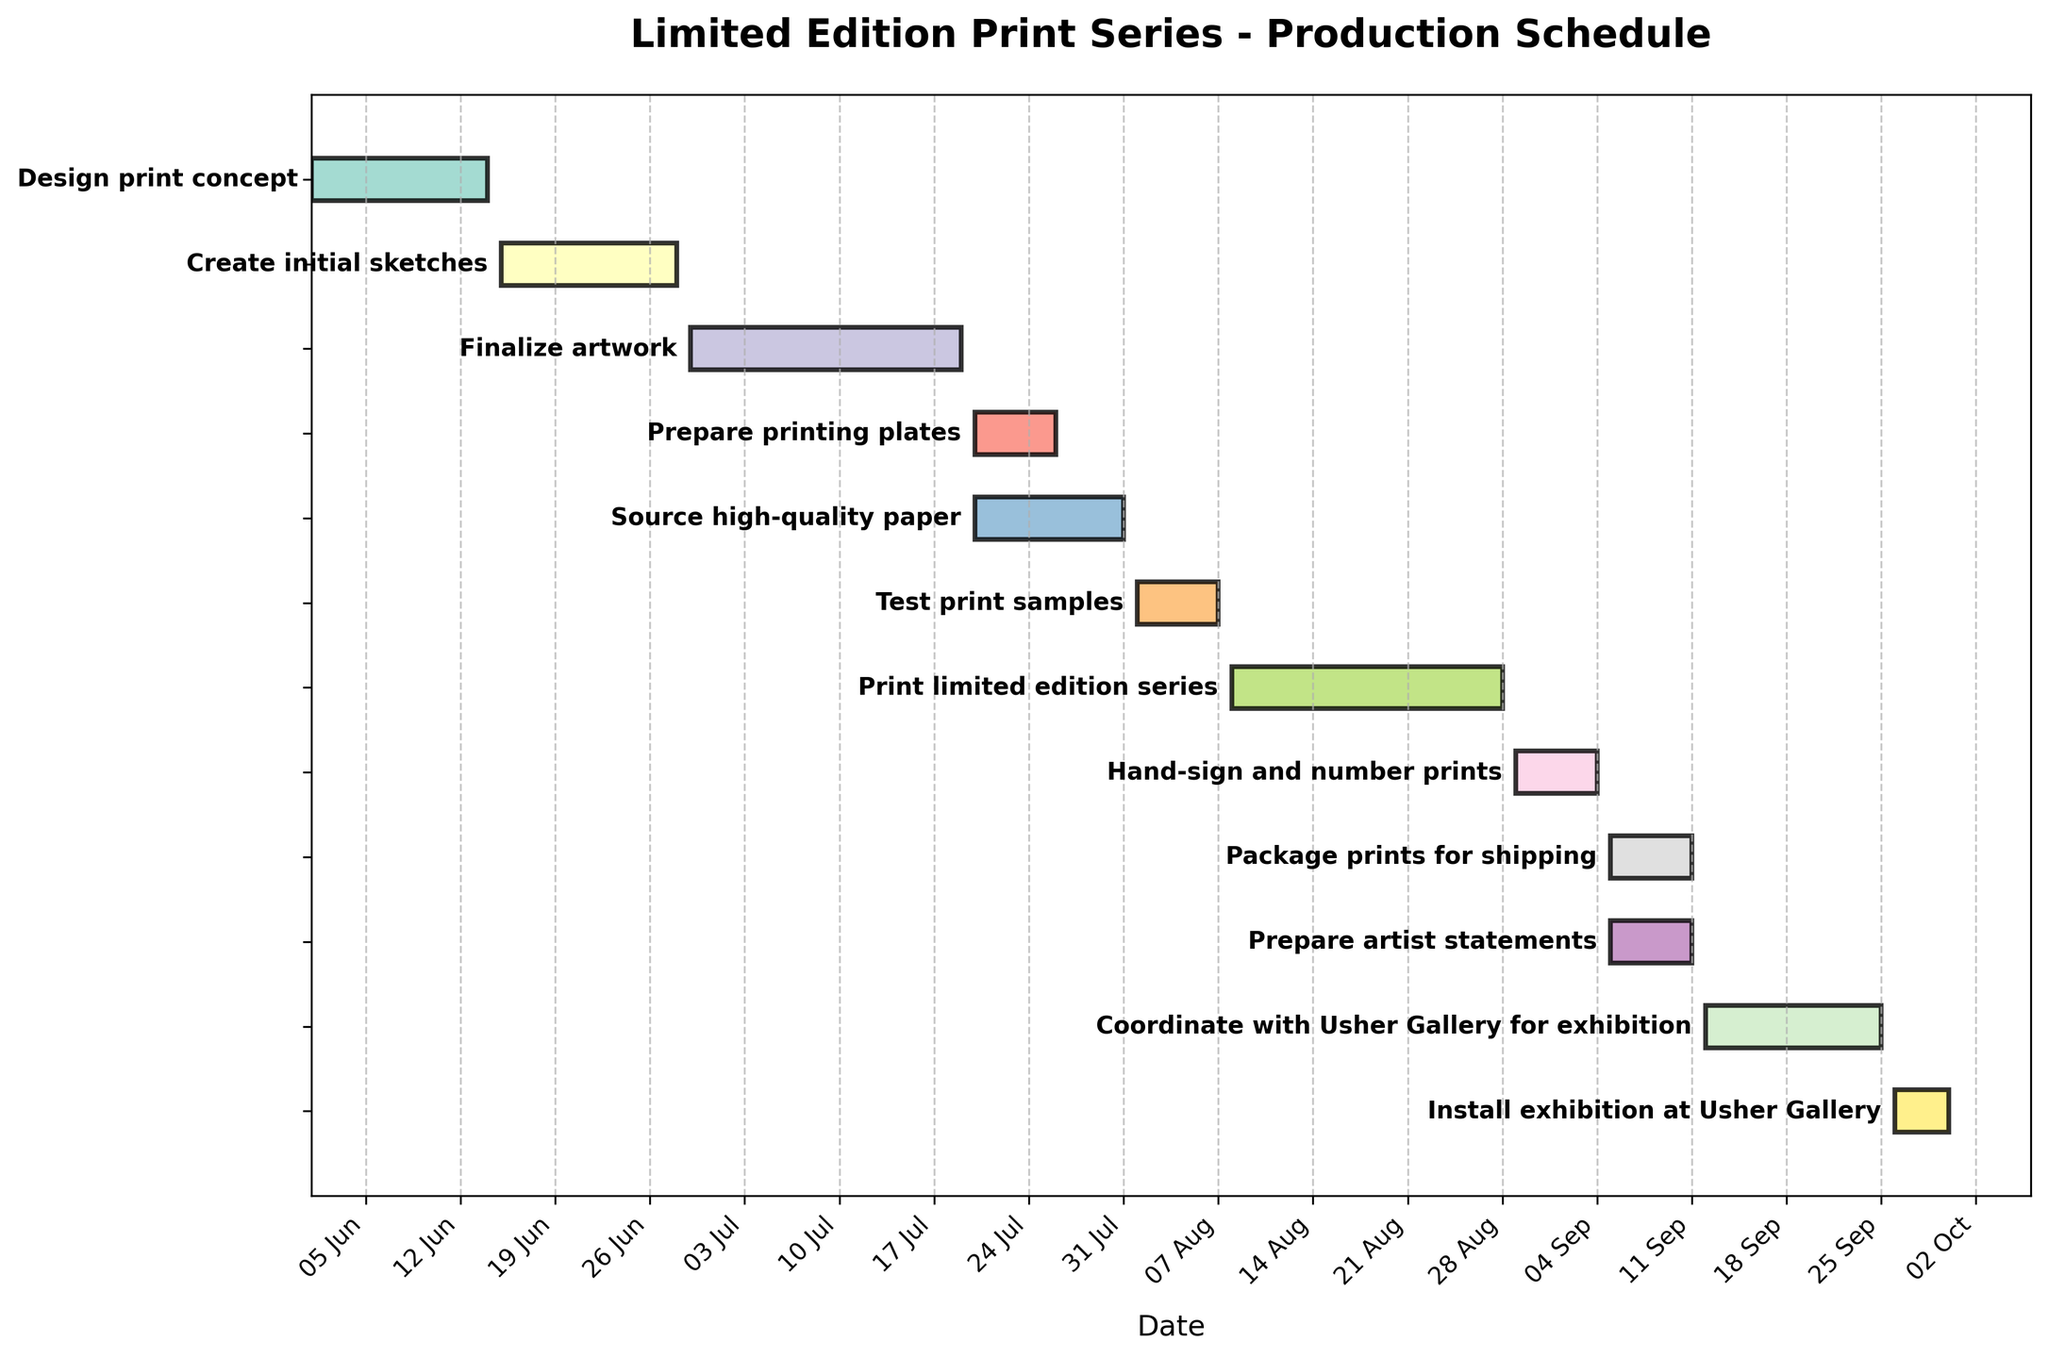What is the title of the Gantt Chart? The title is usually found at the top of the chart and often describes the chart's subject.
Answer: "Limited Edition Print Series - Production Schedule" How many tasks are listed in the Gantt Chart? Count the number of distinct bars or rows representing tasks in the chart.
Answer: 12 Which task takes the longest duration to complete? Identify the task that has the longest bar (duration) on the chart. This is found by comparing the lengths of the horizontal bars representing each task.
Answer: "Finalize artwork" Which tasks start on July 20, 2023? Identify bars starting on July 20 by looking for the leftmost point of the horizontal bars aligned with this date.
Answer: "Prepare printing plates" and "Source high-quality paper" Which tasks overlap in duration with the "Print limited edition series" task? Look for tasks that have any portion of their horizontal bars aligned with the timeline of "Print limited edition series" (August 8 - August 28).
Answer: None When does the "Coordinate with Usher Gallery for exhibition" task begin and end? Locate the bar for the specific task and note its start and end dates on the x-axis.
Answer: It begins on September 12, 2023, and ends on September 25, 2023 Which task is scheduled to start immediately after "Test print samples"? Find the end date of "Test print samples" and locate the task on the schedule that begins immediately the next day.
Answer: "Print limited edition series" What is the total duration of all tasks combined? Sum up the durations of all tasks (in days) by adding each task's duration displayed as the length of its horizontal bar.
Answer: 123 days How does the duration of "Hand-sign and number prints" compare to "Package prints for shipping"? Measure the lengths of the horizontal bars for these tasks to see which is longer or if they are the same.
Answer: "Hand-sign and number prints" is shorter 